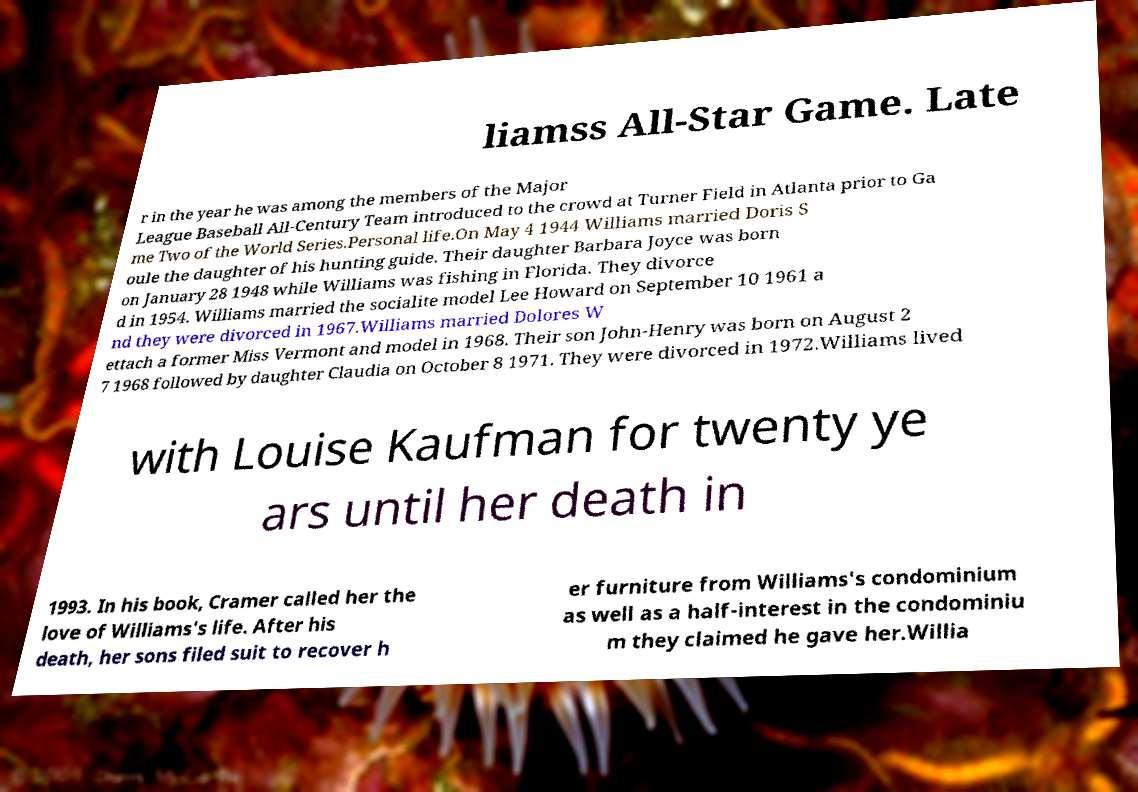Can you accurately transcribe the text from the provided image for me? liamss All-Star Game. Late r in the year he was among the members of the Major League Baseball All-Century Team introduced to the crowd at Turner Field in Atlanta prior to Ga me Two of the World Series.Personal life.On May 4 1944 Williams married Doris S oule the daughter of his hunting guide. Their daughter Barbara Joyce was born on January 28 1948 while Williams was fishing in Florida. They divorce d in 1954. Williams married the socialite model Lee Howard on September 10 1961 a nd they were divorced in 1967.Williams married Dolores W ettach a former Miss Vermont and model in 1968. Their son John-Henry was born on August 2 7 1968 followed by daughter Claudia on October 8 1971. They were divorced in 1972.Williams lived with Louise Kaufman for twenty ye ars until her death in 1993. In his book, Cramer called her the love of Williams's life. After his death, her sons filed suit to recover h er furniture from Williams's condominium as well as a half-interest in the condominiu m they claimed he gave her.Willia 